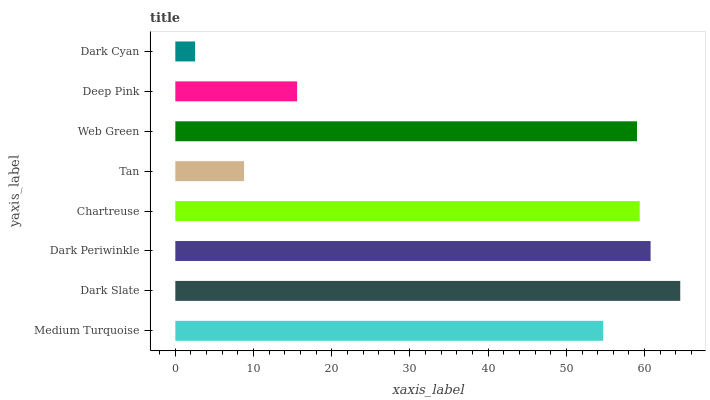Is Dark Cyan the minimum?
Answer yes or no. Yes. Is Dark Slate the maximum?
Answer yes or no. Yes. Is Dark Periwinkle the minimum?
Answer yes or no. No. Is Dark Periwinkle the maximum?
Answer yes or no. No. Is Dark Slate greater than Dark Periwinkle?
Answer yes or no. Yes. Is Dark Periwinkle less than Dark Slate?
Answer yes or no. Yes. Is Dark Periwinkle greater than Dark Slate?
Answer yes or no. No. Is Dark Slate less than Dark Periwinkle?
Answer yes or no. No. Is Web Green the high median?
Answer yes or no. Yes. Is Medium Turquoise the low median?
Answer yes or no. Yes. Is Medium Turquoise the high median?
Answer yes or no. No. Is Dark Periwinkle the low median?
Answer yes or no. No. 